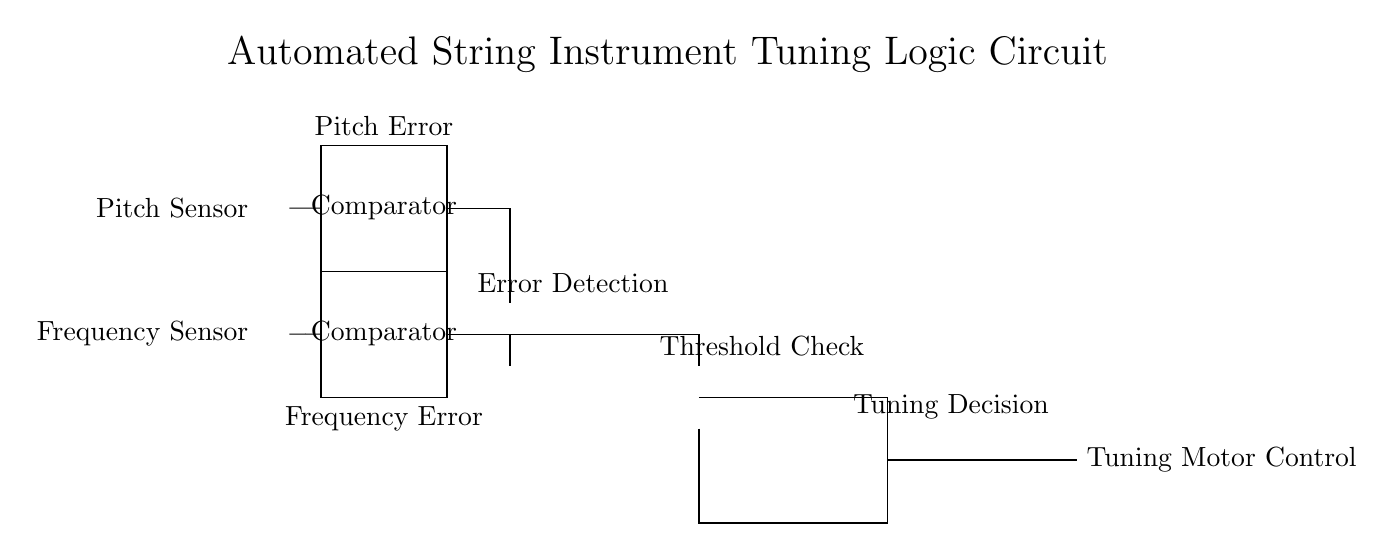What components are present in the circuit diagram? The circuit diagram includes two pitch sensors, two frequency sensors, two comparators, one XOR gate, one AND gate, one OR gate, and a tuning motor control.
Answer: pitch sensors, frequency sensors, comparators, XOR gate, AND gate, OR gate, tuning motor control What is the function of the XOR gate in this logic circuit? The XOR gate in this circuit is responsible for error detection between the outputs of the two comparators, determining if there is a mismatch between pitch and frequency measurements.
Answer: Error detection How many comparators are used in this circuit? The circuit diagram shows two comparators, each having distinct roles in measuring pitch and frequency errors, which collectively help in the automation of string tuning.
Answer: 2 Which logic gate combines the outputs of the AND gate and the OR gate? The outputs from the AND gate and the OR gate are combined in the final stage of the circuit using the OR gate for the tuning decision process, allowing for actuation based on multiple conditions.
Answer: OR gate What type of operation does the AND gate perform in this circuit? The AND gate in this setup executes a threshold check, which requires both inputs (presumably indicating error signals) to be true for the output to be activated, ensuring precise tuning decisions are made only when required conditions are met.
Answer: Threshold check What is the purpose of the tuning motor control? The tuning motor control manages the physical tuning adjustments needed on the string instruments, actuating based on the outcomes of the preceding logic operations that determine the required tuning corrections.
Answer: Manage tuning adjustments What does the term "Pitch Error" signify in this circuit? "Pitch Error" represents the signal output from the pitch comparator that indicates the difference between the actual pitch produced by the string instrument and the desired pitch, serving as a crucial input for automatic tuning.
Answer: Difference in pitch 